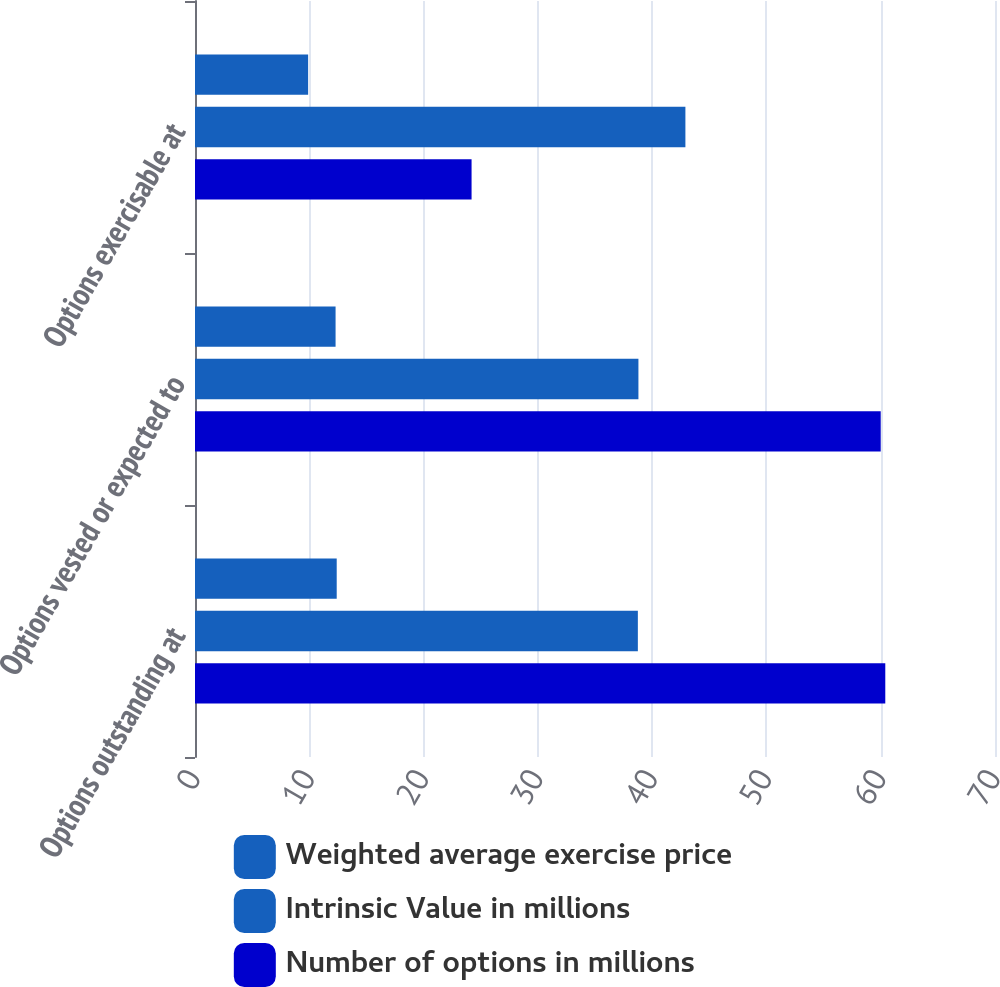Convert chart to OTSL. <chart><loc_0><loc_0><loc_500><loc_500><stacked_bar_chart><ecel><fcel>Options outstanding at<fcel>Options vested or expected to<fcel>Options exercisable at<nl><fcel>Weighted average exercise price<fcel>12.4<fcel>12.3<fcel>9.9<nl><fcel>Intrinsic Value in millions<fcel>38.75<fcel>38.8<fcel>42.91<nl><fcel>Number of options in millions<fcel>60.4<fcel>60<fcel>24.2<nl></chart> 